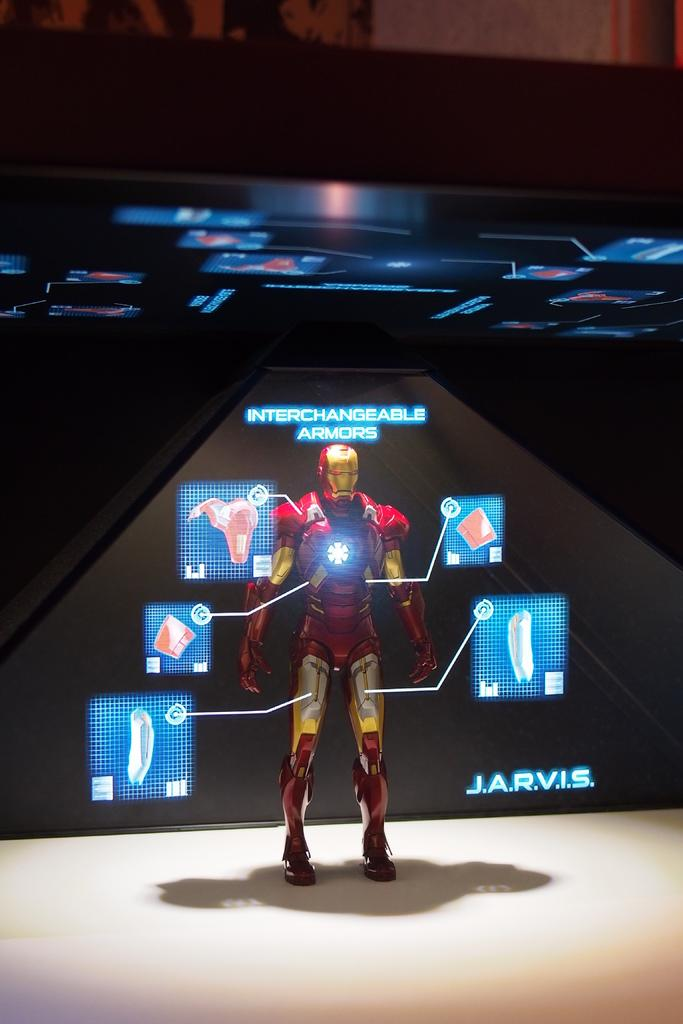<image>
Offer a succinct explanation of the picture presented. A mannequin with a mask is on display with a sign above it that says interchangeable armors. 